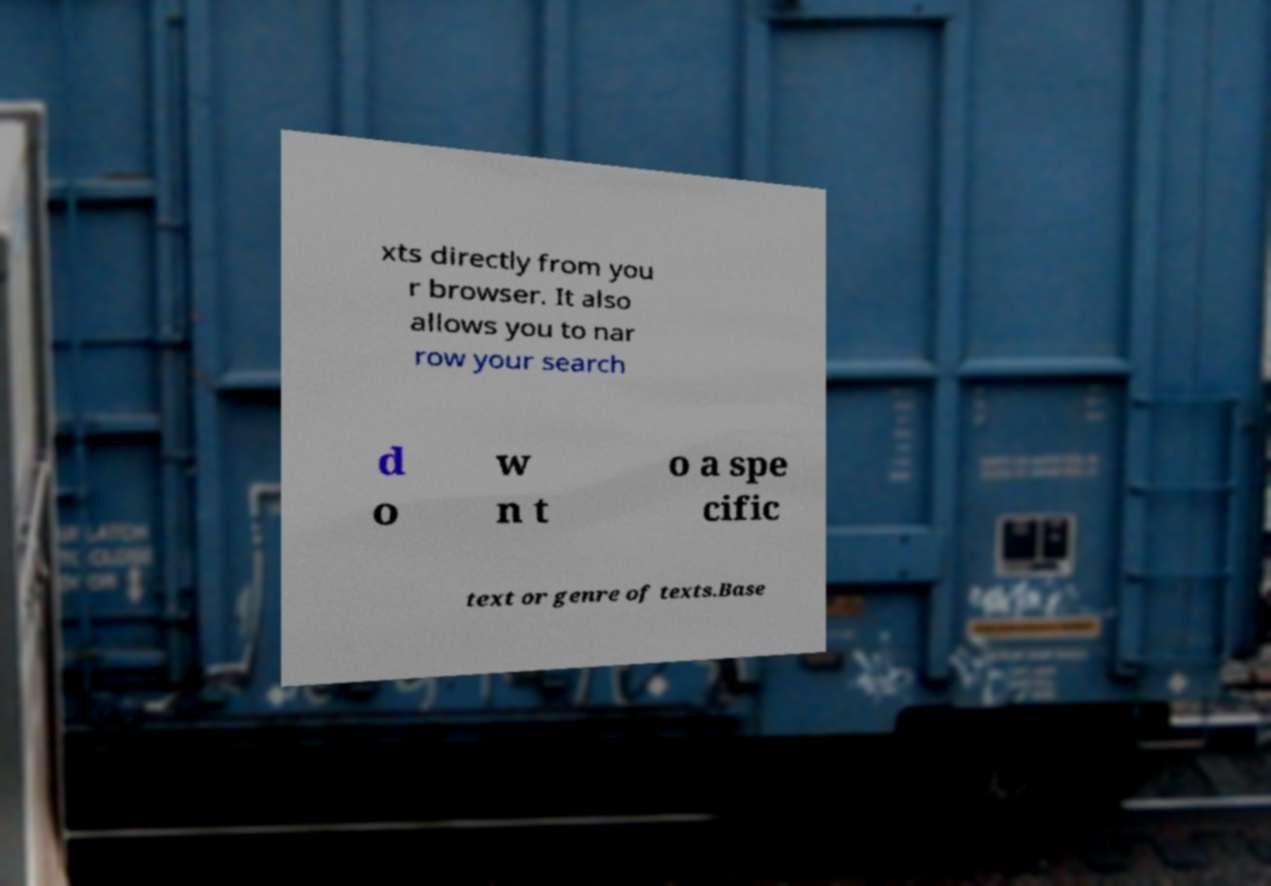Please identify and transcribe the text found in this image. xts directly from you r browser. It also allows you to nar row your search d o w n t o a spe cific text or genre of texts.Base 